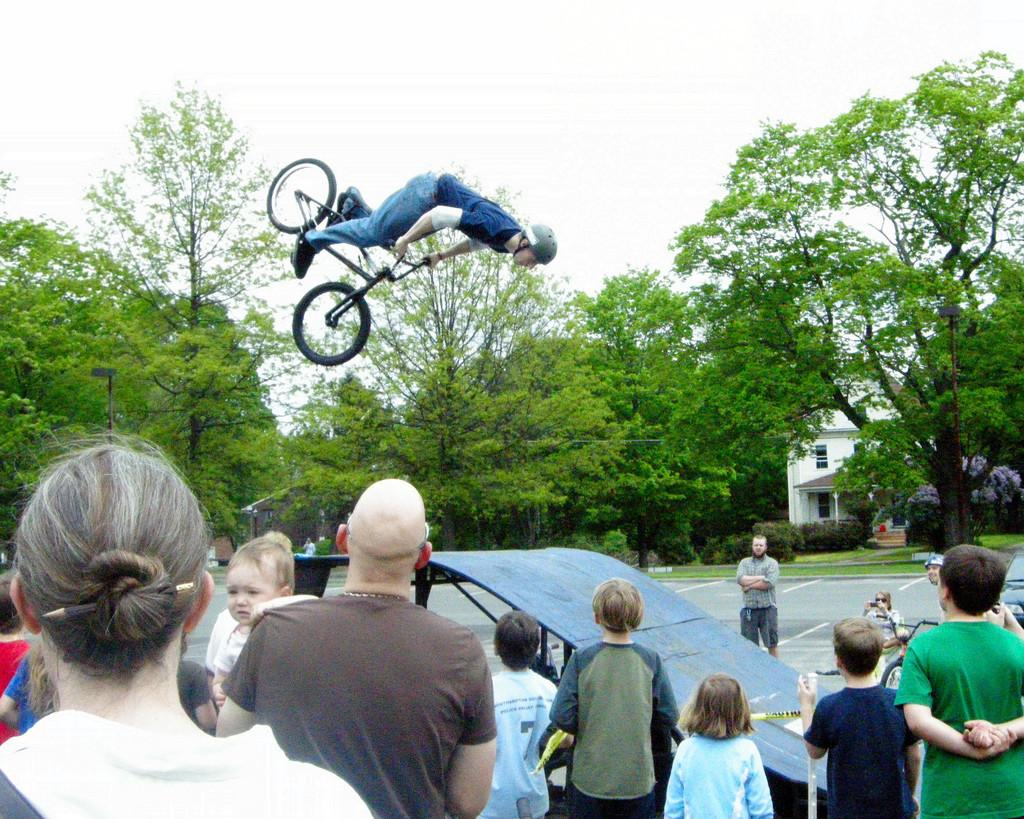What is the main subject of the image? The main subject of the image is a man. What is the man doing in the image? The man is jumping with a cycle in the image. Are there any other people in the image? Yes, people are observing the man in the image. What can be seen in the background of the image? There are trees in the image, and the sky is visible at the top. What type of basin is visible in the image? There is no basin present in the image. 